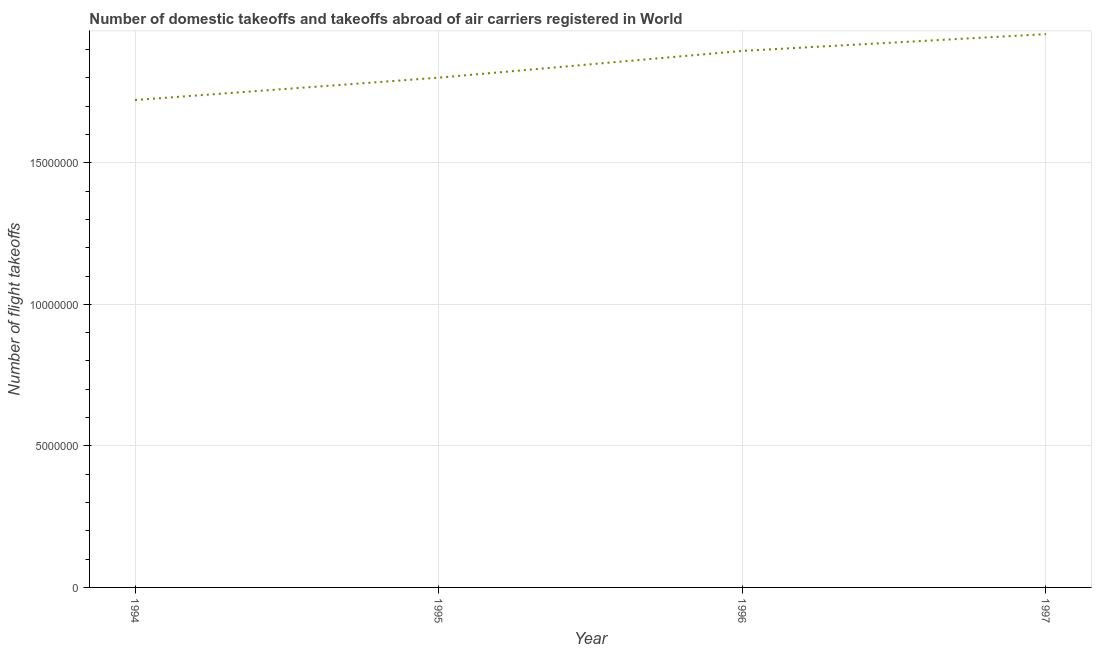What is the number of flight takeoffs in 1994?
Provide a succinct answer. 1.72e+07. Across all years, what is the maximum number of flight takeoffs?
Offer a terse response. 1.95e+07. Across all years, what is the minimum number of flight takeoffs?
Make the answer very short. 1.72e+07. What is the sum of the number of flight takeoffs?
Give a very brief answer. 7.37e+07. What is the difference between the number of flight takeoffs in 1995 and 1996?
Provide a short and direct response. -9.45e+05. What is the average number of flight takeoffs per year?
Your answer should be very brief. 1.84e+07. What is the median number of flight takeoffs?
Ensure brevity in your answer.  1.85e+07. Do a majority of the years between 1995 and 1997 (inclusive) have number of flight takeoffs greater than 9000000 ?
Ensure brevity in your answer.  Yes. What is the ratio of the number of flight takeoffs in 1995 to that in 1996?
Make the answer very short. 0.95. Is the difference between the number of flight takeoffs in 1995 and 1996 greater than the difference between any two years?
Offer a very short reply. No. What is the difference between the highest and the second highest number of flight takeoffs?
Offer a terse response. 5.93e+05. What is the difference between the highest and the lowest number of flight takeoffs?
Provide a succinct answer. 2.33e+06. Does the number of flight takeoffs monotonically increase over the years?
Keep it short and to the point. Yes. Does the graph contain any zero values?
Offer a terse response. No. What is the title of the graph?
Your answer should be compact. Number of domestic takeoffs and takeoffs abroad of air carriers registered in World. What is the label or title of the X-axis?
Keep it short and to the point. Year. What is the label or title of the Y-axis?
Make the answer very short. Number of flight takeoffs. What is the Number of flight takeoffs of 1994?
Keep it short and to the point. 1.72e+07. What is the Number of flight takeoffs of 1995?
Keep it short and to the point. 1.80e+07. What is the Number of flight takeoffs of 1996?
Make the answer very short. 1.90e+07. What is the Number of flight takeoffs of 1997?
Provide a short and direct response. 1.95e+07. What is the difference between the Number of flight takeoffs in 1994 and 1995?
Provide a short and direct response. -7.89e+05. What is the difference between the Number of flight takeoffs in 1994 and 1996?
Keep it short and to the point. -1.73e+06. What is the difference between the Number of flight takeoffs in 1994 and 1997?
Your response must be concise. -2.33e+06. What is the difference between the Number of flight takeoffs in 1995 and 1996?
Give a very brief answer. -9.45e+05. What is the difference between the Number of flight takeoffs in 1995 and 1997?
Ensure brevity in your answer.  -1.54e+06. What is the difference between the Number of flight takeoffs in 1996 and 1997?
Your answer should be very brief. -5.93e+05. What is the ratio of the Number of flight takeoffs in 1994 to that in 1995?
Offer a very short reply. 0.96. What is the ratio of the Number of flight takeoffs in 1994 to that in 1996?
Your answer should be very brief. 0.91. What is the ratio of the Number of flight takeoffs in 1994 to that in 1997?
Give a very brief answer. 0.88. What is the ratio of the Number of flight takeoffs in 1995 to that in 1997?
Your answer should be compact. 0.92. What is the ratio of the Number of flight takeoffs in 1996 to that in 1997?
Your answer should be compact. 0.97. 